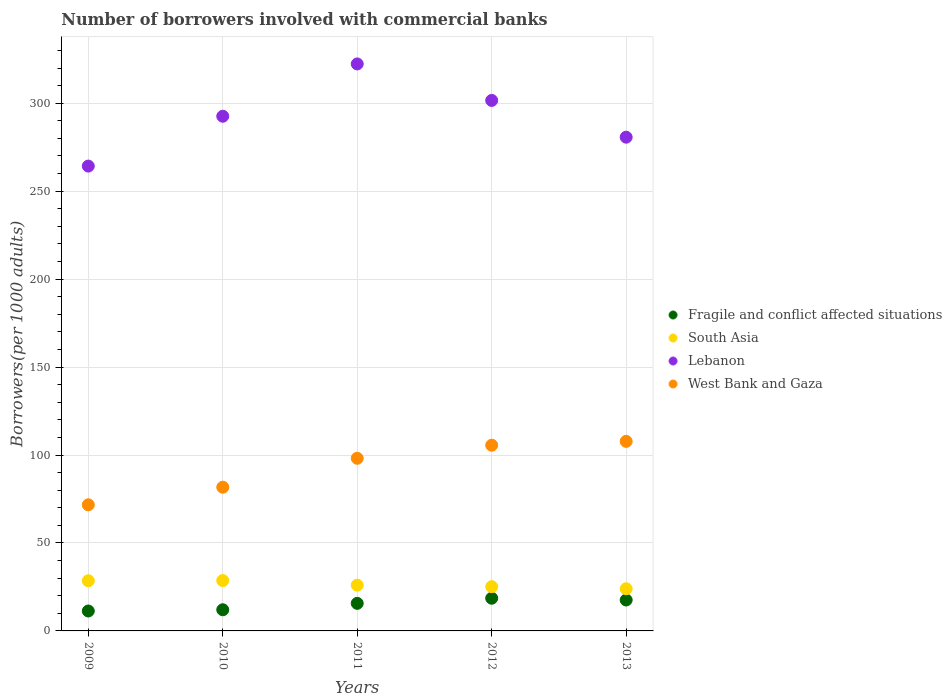What is the number of borrowers involved with commercial banks in West Bank and Gaza in 2009?
Keep it short and to the point. 71.69. Across all years, what is the maximum number of borrowers involved with commercial banks in West Bank and Gaza?
Provide a short and direct response. 107.75. Across all years, what is the minimum number of borrowers involved with commercial banks in Fragile and conflict affected situations?
Your answer should be compact. 11.33. In which year was the number of borrowers involved with commercial banks in South Asia minimum?
Make the answer very short. 2013. What is the total number of borrowers involved with commercial banks in South Asia in the graph?
Provide a short and direct response. 132.29. What is the difference between the number of borrowers involved with commercial banks in Fragile and conflict affected situations in 2010 and that in 2011?
Ensure brevity in your answer.  -3.64. What is the difference between the number of borrowers involved with commercial banks in West Bank and Gaza in 2010 and the number of borrowers involved with commercial banks in Lebanon in 2009?
Keep it short and to the point. -182.56. What is the average number of borrowers involved with commercial banks in West Bank and Gaza per year?
Offer a terse response. 92.97. In the year 2011, what is the difference between the number of borrowers involved with commercial banks in West Bank and Gaza and number of borrowers involved with commercial banks in South Asia?
Give a very brief answer. 72.13. What is the ratio of the number of borrowers involved with commercial banks in Lebanon in 2010 to that in 2012?
Keep it short and to the point. 0.97. What is the difference between the highest and the second highest number of borrowers involved with commercial banks in West Bank and Gaza?
Make the answer very short. 2.17. What is the difference between the highest and the lowest number of borrowers involved with commercial banks in Lebanon?
Your response must be concise. 58.07. In how many years, is the number of borrowers involved with commercial banks in West Bank and Gaza greater than the average number of borrowers involved with commercial banks in West Bank and Gaza taken over all years?
Give a very brief answer. 3. Is it the case that in every year, the sum of the number of borrowers involved with commercial banks in West Bank and Gaza and number of borrowers involved with commercial banks in Lebanon  is greater than the sum of number of borrowers involved with commercial banks in South Asia and number of borrowers involved with commercial banks in Fragile and conflict affected situations?
Provide a short and direct response. Yes. Is the number of borrowers involved with commercial banks in Fragile and conflict affected situations strictly less than the number of borrowers involved with commercial banks in South Asia over the years?
Your response must be concise. Yes. What is the difference between two consecutive major ticks on the Y-axis?
Give a very brief answer. 50. How are the legend labels stacked?
Provide a short and direct response. Vertical. What is the title of the graph?
Offer a very short reply. Number of borrowers involved with commercial banks. Does "Montenegro" appear as one of the legend labels in the graph?
Ensure brevity in your answer.  No. What is the label or title of the Y-axis?
Offer a terse response. Borrowers(per 1000 adults). What is the Borrowers(per 1000 adults) in Fragile and conflict affected situations in 2009?
Offer a terse response. 11.33. What is the Borrowers(per 1000 adults) of South Asia in 2009?
Your answer should be very brief. 28.52. What is the Borrowers(per 1000 adults) in Lebanon in 2009?
Offer a very short reply. 264.25. What is the Borrowers(per 1000 adults) of West Bank and Gaza in 2009?
Your answer should be compact. 71.69. What is the Borrowers(per 1000 adults) of Fragile and conflict affected situations in 2010?
Offer a very short reply. 12.03. What is the Borrowers(per 1000 adults) of South Asia in 2010?
Provide a succinct answer. 28.64. What is the Borrowers(per 1000 adults) in Lebanon in 2010?
Ensure brevity in your answer.  292.58. What is the Borrowers(per 1000 adults) of West Bank and Gaza in 2010?
Keep it short and to the point. 81.68. What is the Borrowers(per 1000 adults) in Fragile and conflict affected situations in 2011?
Ensure brevity in your answer.  15.67. What is the Borrowers(per 1000 adults) in South Asia in 2011?
Your answer should be compact. 26.01. What is the Borrowers(per 1000 adults) of Lebanon in 2011?
Offer a terse response. 322.32. What is the Borrowers(per 1000 adults) of West Bank and Gaza in 2011?
Provide a short and direct response. 98.13. What is the Borrowers(per 1000 adults) in Fragile and conflict affected situations in 2012?
Your answer should be compact. 18.58. What is the Borrowers(per 1000 adults) of South Asia in 2012?
Your answer should be compact. 25.15. What is the Borrowers(per 1000 adults) of Lebanon in 2012?
Provide a short and direct response. 301.58. What is the Borrowers(per 1000 adults) of West Bank and Gaza in 2012?
Offer a very short reply. 105.58. What is the Borrowers(per 1000 adults) in Fragile and conflict affected situations in 2013?
Give a very brief answer. 17.58. What is the Borrowers(per 1000 adults) of South Asia in 2013?
Keep it short and to the point. 23.97. What is the Borrowers(per 1000 adults) in Lebanon in 2013?
Keep it short and to the point. 280.67. What is the Borrowers(per 1000 adults) in West Bank and Gaza in 2013?
Provide a succinct answer. 107.75. Across all years, what is the maximum Borrowers(per 1000 adults) in Fragile and conflict affected situations?
Your response must be concise. 18.58. Across all years, what is the maximum Borrowers(per 1000 adults) in South Asia?
Offer a terse response. 28.64. Across all years, what is the maximum Borrowers(per 1000 adults) in Lebanon?
Your answer should be compact. 322.32. Across all years, what is the maximum Borrowers(per 1000 adults) in West Bank and Gaza?
Make the answer very short. 107.75. Across all years, what is the minimum Borrowers(per 1000 adults) of Fragile and conflict affected situations?
Make the answer very short. 11.33. Across all years, what is the minimum Borrowers(per 1000 adults) in South Asia?
Your answer should be compact. 23.97. Across all years, what is the minimum Borrowers(per 1000 adults) of Lebanon?
Offer a very short reply. 264.25. Across all years, what is the minimum Borrowers(per 1000 adults) of West Bank and Gaza?
Keep it short and to the point. 71.69. What is the total Borrowers(per 1000 adults) in Fragile and conflict affected situations in the graph?
Your answer should be very brief. 75.19. What is the total Borrowers(per 1000 adults) of South Asia in the graph?
Your response must be concise. 132.29. What is the total Borrowers(per 1000 adults) in Lebanon in the graph?
Give a very brief answer. 1461.39. What is the total Borrowers(per 1000 adults) in West Bank and Gaza in the graph?
Ensure brevity in your answer.  464.84. What is the difference between the Borrowers(per 1000 adults) in Fragile and conflict affected situations in 2009 and that in 2010?
Your response must be concise. -0.7. What is the difference between the Borrowers(per 1000 adults) in South Asia in 2009 and that in 2010?
Your response must be concise. -0.12. What is the difference between the Borrowers(per 1000 adults) in Lebanon in 2009 and that in 2010?
Your answer should be compact. -28.33. What is the difference between the Borrowers(per 1000 adults) in West Bank and Gaza in 2009 and that in 2010?
Offer a very short reply. -9.99. What is the difference between the Borrowers(per 1000 adults) in Fragile and conflict affected situations in 2009 and that in 2011?
Offer a very short reply. -4.34. What is the difference between the Borrowers(per 1000 adults) in South Asia in 2009 and that in 2011?
Make the answer very short. 2.51. What is the difference between the Borrowers(per 1000 adults) in Lebanon in 2009 and that in 2011?
Offer a very short reply. -58.07. What is the difference between the Borrowers(per 1000 adults) in West Bank and Gaza in 2009 and that in 2011?
Make the answer very short. -26.44. What is the difference between the Borrowers(per 1000 adults) of Fragile and conflict affected situations in 2009 and that in 2012?
Your answer should be very brief. -7.25. What is the difference between the Borrowers(per 1000 adults) of South Asia in 2009 and that in 2012?
Keep it short and to the point. 3.37. What is the difference between the Borrowers(per 1000 adults) of Lebanon in 2009 and that in 2012?
Make the answer very short. -37.33. What is the difference between the Borrowers(per 1000 adults) of West Bank and Gaza in 2009 and that in 2012?
Your answer should be very brief. -33.89. What is the difference between the Borrowers(per 1000 adults) of Fragile and conflict affected situations in 2009 and that in 2013?
Give a very brief answer. -6.25. What is the difference between the Borrowers(per 1000 adults) in South Asia in 2009 and that in 2013?
Make the answer very short. 4.55. What is the difference between the Borrowers(per 1000 adults) in Lebanon in 2009 and that in 2013?
Ensure brevity in your answer.  -16.42. What is the difference between the Borrowers(per 1000 adults) of West Bank and Gaza in 2009 and that in 2013?
Make the answer very short. -36.06. What is the difference between the Borrowers(per 1000 adults) of Fragile and conflict affected situations in 2010 and that in 2011?
Offer a very short reply. -3.64. What is the difference between the Borrowers(per 1000 adults) in South Asia in 2010 and that in 2011?
Make the answer very short. 2.63. What is the difference between the Borrowers(per 1000 adults) in Lebanon in 2010 and that in 2011?
Give a very brief answer. -29.74. What is the difference between the Borrowers(per 1000 adults) of West Bank and Gaza in 2010 and that in 2011?
Offer a terse response. -16.45. What is the difference between the Borrowers(per 1000 adults) in Fragile and conflict affected situations in 2010 and that in 2012?
Your response must be concise. -6.55. What is the difference between the Borrowers(per 1000 adults) of South Asia in 2010 and that in 2012?
Make the answer very short. 3.49. What is the difference between the Borrowers(per 1000 adults) of Lebanon in 2010 and that in 2012?
Provide a succinct answer. -9. What is the difference between the Borrowers(per 1000 adults) in West Bank and Gaza in 2010 and that in 2012?
Your answer should be very brief. -23.89. What is the difference between the Borrowers(per 1000 adults) in Fragile and conflict affected situations in 2010 and that in 2013?
Your response must be concise. -5.55. What is the difference between the Borrowers(per 1000 adults) in South Asia in 2010 and that in 2013?
Offer a terse response. 4.68. What is the difference between the Borrowers(per 1000 adults) of Lebanon in 2010 and that in 2013?
Ensure brevity in your answer.  11.91. What is the difference between the Borrowers(per 1000 adults) in West Bank and Gaza in 2010 and that in 2013?
Offer a terse response. -26.07. What is the difference between the Borrowers(per 1000 adults) in Fragile and conflict affected situations in 2011 and that in 2012?
Give a very brief answer. -2.91. What is the difference between the Borrowers(per 1000 adults) of South Asia in 2011 and that in 2012?
Provide a succinct answer. 0.86. What is the difference between the Borrowers(per 1000 adults) in Lebanon in 2011 and that in 2012?
Make the answer very short. 20.74. What is the difference between the Borrowers(per 1000 adults) of West Bank and Gaza in 2011 and that in 2012?
Make the answer very short. -7.44. What is the difference between the Borrowers(per 1000 adults) of Fragile and conflict affected situations in 2011 and that in 2013?
Your answer should be compact. -1.91. What is the difference between the Borrowers(per 1000 adults) of South Asia in 2011 and that in 2013?
Provide a short and direct response. 2.04. What is the difference between the Borrowers(per 1000 adults) in Lebanon in 2011 and that in 2013?
Your response must be concise. 41.65. What is the difference between the Borrowers(per 1000 adults) of West Bank and Gaza in 2011 and that in 2013?
Provide a short and direct response. -9.62. What is the difference between the Borrowers(per 1000 adults) in South Asia in 2012 and that in 2013?
Make the answer very short. 1.18. What is the difference between the Borrowers(per 1000 adults) of Lebanon in 2012 and that in 2013?
Provide a short and direct response. 20.91. What is the difference between the Borrowers(per 1000 adults) in West Bank and Gaza in 2012 and that in 2013?
Your response must be concise. -2.17. What is the difference between the Borrowers(per 1000 adults) of Fragile and conflict affected situations in 2009 and the Borrowers(per 1000 adults) of South Asia in 2010?
Offer a terse response. -17.31. What is the difference between the Borrowers(per 1000 adults) of Fragile and conflict affected situations in 2009 and the Borrowers(per 1000 adults) of Lebanon in 2010?
Your response must be concise. -281.25. What is the difference between the Borrowers(per 1000 adults) of Fragile and conflict affected situations in 2009 and the Borrowers(per 1000 adults) of West Bank and Gaza in 2010?
Keep it short and to the point. -70.36. What is the difference between the Borrowers(per 1000 adults) in South Asia in 2009 and the Borrowers(per 1000 adults) in Lebanon in 2010?
Ensure brevity in your answer.  -264.06. What is the difference between the Borrowers(per 1000 adults) of South Asia in 2009 and the Borrowers(per 1000 adults) of West Bank and Gaza in 2010?
Make the answer very short. -53.16. What is the difference between the Borrowers(per 1000 adults) of Lebanon in 2009 and the Borrowers(per 1000 adults) of West Bank and Gaza in 2010?
Ensure brevity in your answer.  182.56. What is the difference between the Borrowers(per 1000 adults) of Fragile and conflict affected situations in 2009 and the Borrowers(per 1000 adults) of South Asia in 2011?
Offer a terse response. -14.68. What is the difference between the Borrowers(per 1000 adults) of Fragile and conflict affected situations in 2009 and the Borrowers(per 1000 adults) of Lebanon in 2011?
Make the answer very short. -310.99. What is the difference between the Borrowers(per 1000 adults) of Fragile and conflict affected situations in 2009 and the Borrowers(per 1000 adults) of West Bank and Gaza in 2011?
Your response must be concise. -86.81. What is the difference between the Borrowers(per 1000 adults) of South Asia in 2009 and the Borrowers(per 1000 adults) of Lebanon in 2011?
Provide a short and direct response. -293.8. What is the difference between the Borrowers(per 1000 adults) of South Asia in 2009 and the Borrowers(per 1000 adults) of West Bank and Gaza in 2011?
Provide a succinct answer. -69.61. What is the difference between the Borrowers(per 1000 adults) of Lebanon in 2009 and the Borrowers(per 1000 adults) of West Bank and Gaza in 2011?
Your response must be concise. 166.11. What is the difference between the Borrowers(per 1000 adults) of Fragile and conflict affected situations in 2009 and the Borrowers(per 1000 adults) of South Asia in 2012?
Keep it short and to the point. -13.82. What is the difference between the Borrowers(per 1000 adults) in Fragile and conflict affected situations in 2009 and the Borrowers(per 1000 adults) in Lebanon in 2012?
Give a very brief answer. -290.25. What is the difference between the Borrowers(per 1000 adults) in Fragile and conflict affected situations in 2009 and the Borrowers(per 1000 adults) in West Bank and Gaza in 2012?
Provide a short and direct response. -94.25. What is the difference between the Borrowers(per 1000 adults) of South Asia in 2009 and the Borrowers(per 1000 adults) of Lebanon in 2012?
Your answer should be compact. -273.06. What is the difference between the Borrowers(per 1000 adults) in South Asia in 2009 and the Borrowers(per 1000 adults) in West Bank and Gaza in 2012?
Your answer should be very brief. -77.06. What is the difference between the Borrowers(per 1000 adults) in Lebanon in 2009 and the Borrowers(per 1000 adults) in West Bank and Gaza in 2012?
Offer a very short reply. 158.67. What is the difference between the Borrowers(per 1000 adults) of Fragile and conflict affected situations in 2009 and the Borrowers(per 1000 adults) of South Asia in 2013?
Make the answer very short. -12.64. What is the difference between the Borrowers(per 1000 adults) in Fragile and conflict affected situations in 2009 and the Borrowers(per 1000 adults) in Lebanon in 2013?
Keep it short and to the point. -269.34. What is the difference between the Borrowers(per 1000 adults) of Fragile and conflict affected situations in 2009 and the Borrowers(per 1000 adults) of West Bank and Gaza in 2013?
Provide a succinct answer. -96.42. What is the difference between the Borrowers(per 1000 adults) in South Asia in 2009 and the Borrowers(per 1000 adults) in Lebanon in 2013?
Keep it short and to the point. -252.15. What is the difference between the Borrowers(per 1000 adults) in South Asia in 2009 and the Borrowers(per 1000 adults) in West Bank and Gaza in 2013?
Your answer should be compact. -79.23. What is the difference between the Borrowers(per 1000 adults) of Lebanon in 2009 and the Borrowers(per 1000 adults) of West Bank and Gaza in 2013?
Your answer should be very brief. 156.5. What is the difference between the Borrowers(per 1000 adults) in Fragile and conflict affected situations in 2010 and the Borrowers(per 1000 adults) in South Asia in 2011?
Your answer should be very brief. -13.98. What is the difference between the Borrowers(per 1000 adults) in Fragile and conflict affected situations in 2010 and the Borrowers(per 1000 adults) in Lebanon in 2011?
Ensure brevity in your answer.  -310.29. What is the difference between the Borrowers(per 1000 adults) of Fragile and conflict affected situations in 2010 and the Borrowers(per 1000 adults) of West Bank and Gaza in 2011?
Provide a short and direct response. -86.1. What is the difference between the Borrowers(per 1000 adults) of South Asia in 2010 and the Borrowers(per 1000 adults) of Lebanon in 2011?
Your response must be concise. -293.68. What is the difference between the Borrowers(per 1000 adults) in South Asia in 2010 and the Borrowers(per 1000 adults) in West Bank and Gaza in 2011?
Give a very brief answer. -69.49. What is the difference between the Borrowers(per 1000 adults) of Lebanon in 2010 and the Borrowers(per 1000 adults) of West Bank and Gaza in 2011?
Your response must be concise. 194.45. What is the difference between the Borrowers(per 1000 adults) in Fragile and conflict affected situations in 2010 and the Borrowers(per 1000 adults) in South Asia in 2012?
Your answer should be very brief. -13.12. What is the difference between the Borrowers(per 1000 adults) of Fragile and conflict affected situations in 2010 and the Borrowers(per 1000 adults) of Lebanon in 2012?
Offer a terse response. -289.54. What is the difference between the Borrowers(per 1000 adults) in Fragile and conflict affected situations in 2010 and the Borrowers(per 1000 adults) in West Bank and Gaza in 2012?
Your answer should be very brief. -93.55. What is the difference between the Borrowers(per 1000 adults) of South Asia in 2010 and the Borrowers(per 1000 adults) of Lebanon in 2012?
Offer a very short reply. -272.94. What is the difference between the Borrowers(per 1000 adults) of South Asia in 2010 and the Borrowers(per 1000 adults) of West Bank and Gaza in 2012?
Offer a very short reply. -76.94. What is the difference between the Borrowers(per 1000 adults) of Lebanon in 2010 and the Borrowers(per 1000 adults) of West Bank and Gaza in 2012?
Ensure brevity in your answer.  187. What is the difference between the Borrowers(per 1000 adults) in Fragile and conflict affected situations in 2010 and the Borrowers(per 1000 adults) in South Asia in 2013?
Your response must be concise. -11.93. What is the difference between the Borrowers(per 1000 adults) of Fragile and conflict affected situations in 2010 and the Borrowers(per 1000 adults) of Lebanon in 2013?
Your response must be concise. -268.63. What is the difference between the Borrowers(per 1000 adults) in Fragile and conflict affected situations in 2010 and the Borrowers(per 1000 adults) in West Bank and Gaza in 2013?
Your answer should be compact. -95.72. What is the difference between the Borrowers(per 1000 adults) of South Asia in 2010 and the Borrowers(per 1000 adults) of Lebanon in 2013?
Your answer should be very brief. -252.03. What is the difference between the Borrowers(per 1000 adults) in South Asia in 2010 and the Borrowers(per 1000 adults) in West Bank and Gaza in 2013?
Give a very brief answer. -79.11. What is the difference between the Borrowers(per 1000 adults) of Lebanon in 2010 and the Borrowers(per 1000 adults) of West Bank and Gaza in 2013?
Provide a short and direct response. 184.83. What is the difference between the Borrowers(per 1000 adults) of Fragile and conflict affected situations in 2011 and the Borrowers(per 1000 adults) of South Asia in 2012?
Ensure brevity in your answer.  -9.48. What is the difference between the Borrowers(per 1000 adults) of Fragile and conflict affected situations in 2011 and the Borrowers(per 1000 adults) of Lebanon in 2012?
Provide a short and direct response. -285.91. What is the difference between the Borrowers(per 1000 adults) of Fragile and conflict affected situations in 2011 and the Borrowers(per 1000 adults) of West Bank and Gaza in 2012?
Your answer should be very brief. -89.91. What is the difference between the Borrowers(per 1000 adults) of South Asia in 2011 and the Borrowers(per 1000 adults) of Lebanon in 2012?
Your answer should be compact. -275.57. What is the difference between the Borrowers(per 1000 adults) of South Asia in 2011 and the Borrowers(per 1000 adults) of West Bank and Gaza in 2012?
Ensure brevity in your answer.  -79.57. What is the difference between the Borrowers(per 1000 adults) of Lebanon in 2011 and the Borrowers(per 1000 adults) of West Bank and Gaza in 2012?
Provide a succinct answer. 216.74. What is the difference between the Borrowers(per 1000 adults) of Fragile and conflict affected situations in 2011 and the Borrowers(per 1000 adults) of South Asia in 2013?
Provide a short and direct response. -8.3. What is the difference between the Borrowers(per 1000 adults) in Fragile and conflict affected situations in 2011 and the Borrowers(per 1000 adults) in Lebanon in 2013?
Your response must be concise. -265. What is the difference between the Borrowers(per 1000 adults) in Fragile and conflict affected situations in 2011 and the Borrowers(per 1000 adults) in West Bank and Gaza in 2013?
Make the answer very short. -92.08. What is the difference between the Borrowers(per 1000 adults) of South Asia in 2011 and the Borrowers(per 1000 adults) of Lebanon in 2013?
Give a very brief answer. -254.66. What is the difference between the Borrowers(per 1000 adults) of South Asia in 2011 and the Borrowers(per 1000 adults) of West Bank and Gaza in 2013?
Your answer should be compact. -81.74. What is the difference between the Borrowers(per 1000 adults) of Lebanon in 2011 and the Borrowers(per 1000 adults) of West Bank and Gaza in 2013?
Your response must be concise. 214.57. What is the difference between the Borrowers(per 1000 adults) in Fragile and conflict affected situations in 2012 and the Borrowers(per 1000 adults) in South Asia in 2013?
Offer a terse response. -5.38. What is the difference between the Borrowers(per 1000 adults) of Fragile and conflict affected situations in 2012 and the Borrowers(per 1000 adults) of Lebanon in 2013?
Offer a terse response. -262.08. What is the difference between the Borrowers(per 1000 adults) in Fragile and conflict affected situations in 2012 and the Borrowers(per 1000 adults) in West Bank and Gaza in 2013?
Your response must be concise. -89.17. What is the difference between the Borrowers(per 1000 adults) in South Asia in 2012 and the Borrowers(per 1000 adults) in Lebanon in 2013?
Your response must be concise. -255.52. What is the difference between the Borrowers(per 1000 adults) in South Asia in 2012 and the Borrowers(per 1000 adults) in West Bank and Gaza in 2013?
Offer a terse response. -82.6. What is the difference between the Borrowers(per 1000 adults) in Lebanon in 2012 and the Borrowers(per 1000 adults) in West Bank and Gaza in 2013?
Offer a terse response. 193.83. What is the average Borrowers(per 1000 adults) in Fragile and conflict affected situations per year?
Your answer should be compact. 15.04. What is the average Borrowers(per 1000 adults) in South Asia per year?
Keep it short and to the point. 26.46. What is the average Borrowers(per 1000 adults) of Lebanon per year?
Your response must be concise. 292.28. What is the average Borrowers(per 1000 adults) in West Bank and Gaza per year?
Your response must be concise. 92.97. In the year 2009, what is the difference between the Borrowers(per 1000 adults) of Fragile and conflict affected situations and Borrowers(per 1000 adults) of South Asia?
Provide a succinct answer. -17.19. In the year 2009, what is the difference between the Borrowers(per 1000 adults) in Fragile and conflict affected situations and Borrowers(per 1000 adults) in Lebanon?
Give a very brief answer. -252.92. In the year 2009, what is the difference between the Borrowers(per 1000 adults) in Fragile and conflict affected situations and Borrowers(per 1000 adults) in West Bank and Gaza?
Offer a very short reply. -60.36. In the year 2009, what is the difference between the Borrowers(per 1000 adults) in South Asia and Borrowers(per 1000 adults) in Lebanon?
Your answer should be very brief. -235.73. In the year 2009, what is the difference between the Borrowers(per 1000 adults) of South Asia and Borrowers(per 1000 adults) of West Bank and Gaza?
Offer a very short reply. -43.17. In the year 2009, what is the difference between the Borrowers(per 1000 adults) in Lebanon and Borrowers(per 1000 adults) in West Bank and Gaza?
Give a very brief answer. 192.56. In the year 2010, what is the difference between the Borrowers(per 1000 adults) in Fragile and conflict affected situations and Borrowers(per 1000 adults) in South Asia?
Offer a very short reply. -16.61. In the year 2010, what is the difference between the Borrowers(per 1000 adults) in Fragile and conflict affected situations and Borrowers(per 1000 adults) in Lebanon?
Offer a terse response. -280.55. In the year 2010, what is the difference between the Borrowers(per 1000 adults) in Fragile and conflict affected situations and Borrowers(per 1000 adults) in West Bank and Gaza?
Offer a terse response. -69.65. In the year 2010, what is the difference between the Borrowers(per 1000 adults) of South Asia and Borrowers(per 1000 adults) of Lebanon?
Ensure brevity in your answer.  -263.94. In the year 2010, what is the difference between the Borrowers(per 1000 adults) of South Asia and Borrowers(per 1000 adults) of West Bank and Gaza?
Offer a terse response. -53.04. In the year 2010, what is the difference between the Borrowers(per 1000 adults) in Lebanon and Borrowers(per 1000 adults) in West Bank and Gaza?
Your response must be concise. 210.9. In the year 2011, what is the difference between the Borrowers(per 1000 adults) in Fragile and conflict affected situations and Borrowers(per 1000 adults) in South Asia?
Ensure brevity in your answer.  -10.34. In the year 2011, what is the difference between the Borrowers(per 1000 adults) in Fragile and conflict affected situations and Borrowers(per 1000 adults) in Lebanon?
Your answer should be compact. -306.65. In the year 2011, what is the difference between the Borrowers(per 1000 adults) in Fragile and conflict affected situations and Borrowers(per 1000 adults) in West Bank and Gaza?
Ensure brevity in your answer.  -82.47. In the year 2011, what is the difference between the Borrowers(per 1000 adults) in South Asia and Borrowers(per 1000 adults) in Lebanon?
Offer a very short reply. -296.31. In the year 2011, what is the difference between the Borrowers(per 1000 adults) of South Asia and Borrowers(per 1000 adults) of West Bank and Gaza?
Keep it short and to the point. -72.13. In the year 2011, what is the difference between the Borrowers(per 1000 adults) in Lebanon and Borrowers(per 1000 adults) in West Bank and Gaza?
Give a very brief answer. 224.19. In the year 2012, what is the difference between the Borrowers(per 1000 adults) in Fragile and conflict affected situations and Borrowers(per 1000 adults) in South Asia?
Your answer should be compact. -6.57. In the year 2012, what is the difference between the Borrowers(per 1000 adults) in Fragile and conflict affected situations and Borrowers(per 1000 adults) in Lebanon?
Provide a short and direct response. -282.99. In the year 2012, what is the difference between the Borrowers(per 1000 adults) in Fragile and conflict affected situations and Borrowers(per 1000 adults) in West Bank and Gaza?
Provide a short and direct response. -87. In the year 2012, what is the difference between the Borrowers(per 1000 adults) of South Asia and Borrowers(per 1000 adults) of Lebanon?
Ensure brevity in your answer.  -276.43. In the year 2012, what is the difference between the Borrowers(per 1000 adults) of South Asia and Borrowers(per 1000 adults) of West Bank and Gaza?
Give a very brief answer. -80.43. In the year 2012, what is the difference between the Borrowers(per 1000 adults) of Lebanon and Borrowers(per 1000 adults) of West Bank and Gaza?
Ensure brevity in your answer.  196. In the year 2013, what is the difference between the Borrowers(per 1000 adults) of Fragile and conflict affected situations and Borrowers(per 1000 adults) of South Asia?
Give a very brief answer. -6.39. In the year 2013, what is the difference between the Borrowers(per 1000 adults) in Fragile and conflict affected situations and Borrowers(per 1000 adults) in Lebanon?
Provide a short and direct response. -263.09. In the year 2013, what is the difference between the Borrowers(per 1000 adults) in Fragile and conflict affected situations and Borrowers(per 1000 adults) in West Bank and Gaza?
Your answer should be compact. -90.17. In the year 2013, what is the difference between the Borrowers(per 1000 adults) of South Asia and Borrowers(per 1000 adults) of Lebanon?
Offer a terse response. -256.7. In the year 2013, what is the difference between the Borrowers(per 1000 adults) of South Asia and Borrowers(per 1000 adults) of West Bank and Gaza?
Keep it short and to the point. -83.79. In the year 2013, what is the difference between the Borrowers(per 1000 adults) of Lebanon and Borrowers(per 1000 adults) of West Bank and Gaza?
Ensure brevity in your answer.  172.91. What is the ratio of the Borrowers(per 1000 adults) in Fragile and conflict affected situations in 2009 to that in 2010?
Give a very brief answer. 0.94. What is the ratio of the Borrowers(per 1000 adults) in Lebanon in 2009 to that in 2010?
Keep it short and to the point. 0.9. What is the ratio of the Borrowers(per 1000 adults) of West Bank and Gaza in 2009 to that in 2010?
Keep it short and to the point. 0.88. What is the ratio of the Borrowers(per 1000 adults) of Fragile and conflict affected situations in 2009 to that in 2011?
Give a very brief answer. 0.72. What is the ratio of the Borrowers(per 1000 adults) in South Asia in 2009 to that in 2011?
Provide a succinct answer. 1.1. What is the ratio of the Borrowers(per 1000 adults) in Lebanon in 2009 to that in 2011?
Provide a short and direct response. 0.82. What is the ratio of the Borrowers(per 1000 adults) of West Bank and Gaza in 2009 to that in 2011?
Keep it short and to the point. 0.73. What is the ratio of the Borrowers(per 1000 adults) in Fragile and conflict affected situations in 2009 to that in 2012?
Keep it short and to the point. 0.61. What is the ratio of the Borrowers(per 1000 adults) of South Asia in 2009 to that in 2012?
Ensure brevity in your answer.  1.13. What is the ratio of the Borrowers(per 1000 adults) in Lebanon in 2009 to that in 2012?
Offer a terse response. 0.88. What is the ratio of the Borrowers(per 1000 adults) of West Bank and Gaza in 2009 to that in 2012?
Your answer should be very brief. 0.68. What is the ratio of the Borrowers(per 1000 adults) in Fragile and conflict affected situations in 2009 to that in 2013?
Offer a terse response. 0.64. What is the ratio of the Borrowers(per 1000 adults) in South Asia in 2009 to that in 2013?
Your answer should be very brief. 1.19. What is the ratio of the Borrowers(per 1000 adults) of Lebanon in 2009 to that in 2013?
Provide a short and direct response. 0.94. What is the ratio of the Borrowers(per 1000 adults) in West Bank and Gaza in 2009 to that in 2013?
Provide a short and direct response. 0.67. What is the ratio of the Borrowers(per 1000 adults) of Fragile and conflict affected situations in 2010 to that in 2011?
Your response must be concise. 0.77. What is the ratio of the Borrowers(per 1000 adults) of South Asia in 2010 to that in 2011?
Offer a very short reply. 1.1. What is the ratio of the Borrowers(per 1000 adults) of Lebanon in 2010 to that in 2011?
Provide a succinct answer. 0.91. What is the ratio of the Borrowers(per 1000 adults) in West Bank and Gaza in 2010 to that in 2011?
Provide a short and direct response. 0.83. What is the ratio of the Borrowers(per 1000 adults) in Fragile and conflict affected situations in 2010 to that in 2012?
Keep it short and to the point. 0.65. What is the ratio of the Borrowers(per 1000 adults) of South Asia in 2010 to that in 2012?
Keep it short and to the point. 1.14. What is the ratio of the Borrowers(per 1000 adults) of Lebanon in 2010 to that in 2012?
Provide a short and direct response. 0.97. What is the ratio of the Borrowers(per 1000 adults) in West Bank and Gaza in 2010 to that in 2012?
Keep it short and to the point. 0.77. What is the ratio of the Borrowers(per 1000 adults) in Fragile and conflict affected situations in 2010 to that in 2013?
Give a very brief answer. 0.68. What is the ratio of the Borrowers(per 1000 adults) in South Asia in 2010 to that in 2013?
Offer a terse response. 1.2. What is the ratio of the Borrowers(per 1000 adults) in Lebanon in 2010 to that in 2013?
Give a very brief answer. 1.04. What is the ratio of the Borrowers(per 1000 adults) in West Bank and Gaza in 2010 to that in 2013?
Your response must be concise. 0.76. What is the ratio of the Borrowers(per 1000 adults) of Fragile and conflict affected situations in 2011 to that in 2012?
Your response must be concise. 0.84. What is the ratio of the Borrowers(per 1000 adults) in South Asia in 2011 to that in 2012?
Offer a very short reply. 1.03. What is the ratio of the Borrowers(per 1000 adults) in Lebanon in 2011 to that in 2012?
Ensure brevity in your answer.  1.07. What is the ratio of the Borrowers(per 1000 adults) in West Bank and Gaza in 2011 to that in 2012?
Your answer should be compact. 0.93. What is the ratio of the Borrowers(per 1000 adults) of Fragile and conflict affected situations in 2011 to that in 2013?
Offer a terse response. 0.89. What is the ratio of the Borrowers(per 1000 adults) in South Asia in 2011 to that in 2013?
Offer a very short reply. 1.09. What is the ratio of the Borrowers(per 1000 adults) in Lebanon in 2011 to that in 2013?
Your answer should be very brief. 1.15. What is the ratio of the Borrowers(per 1000 adults) of West Bank and Gaza in 2011 to that in 2013?
Offer a terse response. 0.91. What is the ratio of the Borrowers(per 1000 adults) in Fragile and conflict affected situations in 2012 to that in 2013?
Provide a short and direct response. 1.06. What is the ratio of the Borrowers(per 1000 adults) in South Asia in 2012 to that in 2013?
Offer a very short reply. 1.05. What is the ratio of the Borrowers(per 1000 adults) of Lebanon in 2012 to that in 2013?
Keep it short and to the point. 1.07. What is the ratio of the Borrowers(per 1000 adults) in West Bank and Gaza in 2012 to that in 2013?
Provide a succinct answer. 0.98. What is the difference between the highest and the second highest Borrowers(per 1000 adults) of South Asia?
Offer a very short reply. 0.12. What is the difference between the highest and the second highest Borrowers(per 1000 adults) of Lebanon?
Ensure brevity in your answer.  20.74. What is the difference between the highest and the second highest Borrowers(per 1000 adults) in West Bank and Gaza?
Offer a terse response. 2.17. What is the difference between the highest and the lowest Borrowers(per 1000 adults) of Fragile and conflict affected situations?
Ensure brevity in your answer.  7.25. What is the difference between the highest and the lowest Borrowers(per 1000 adults) in South Asia?
Keep it short and to the point. 4.68. What is the difference between the highest and the lowest Borrowers(per 1000 adults) of Lebanon?
Ensure brevity in your answer.  58.07. What is the difference between the highest and the lowest Borrowers(per 1000 adults) in West Bank and Gaza?
Your response must be concise. 36.06. 